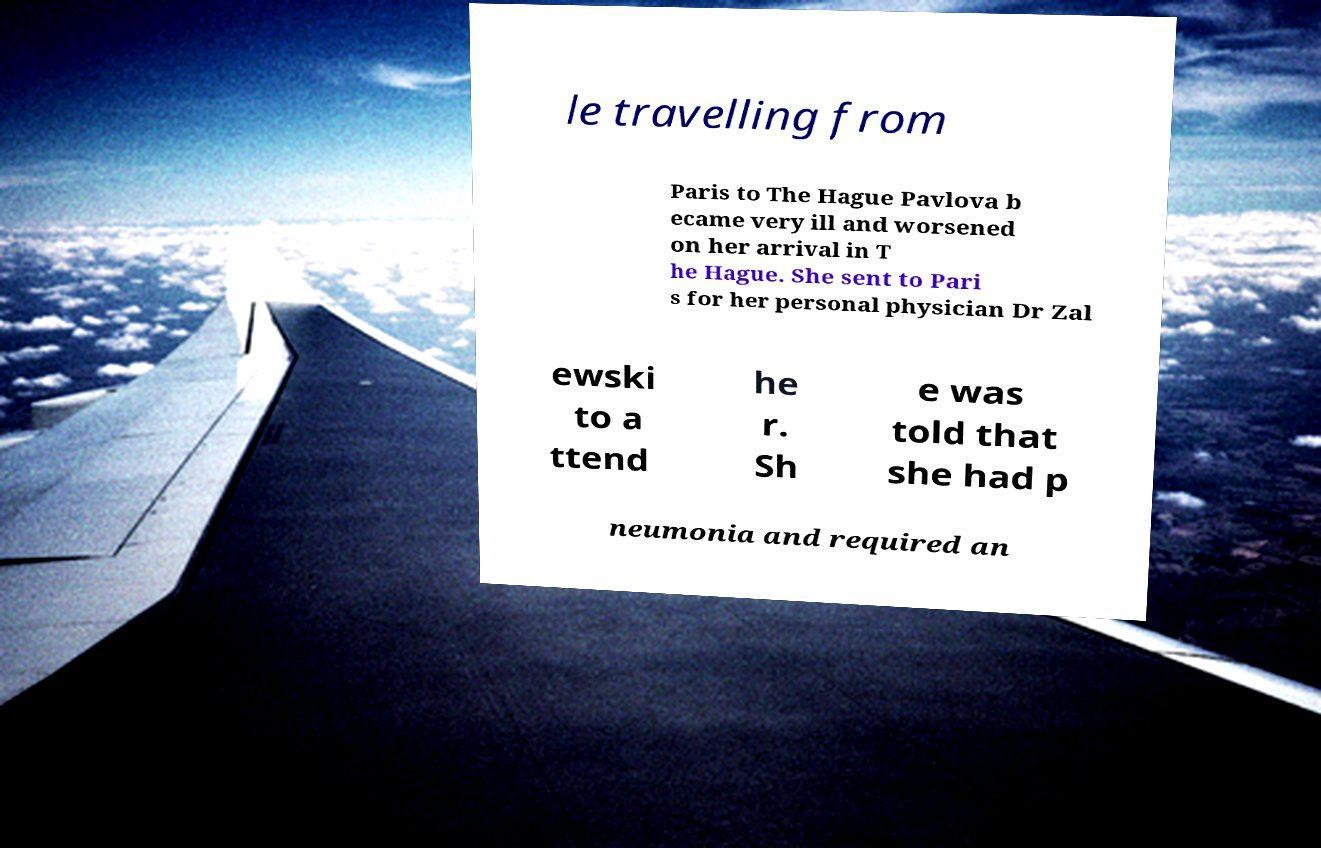Please identify and transcribe the text found in this image. le travelling from Paris to The Hague Pavlova b ecame very ill and worsened on her arrival in T he Hague. She sent to Pari s for her personal physician Dr Zal ewski to a ttend he r. Sh e was told that she had p neumonia and required an 